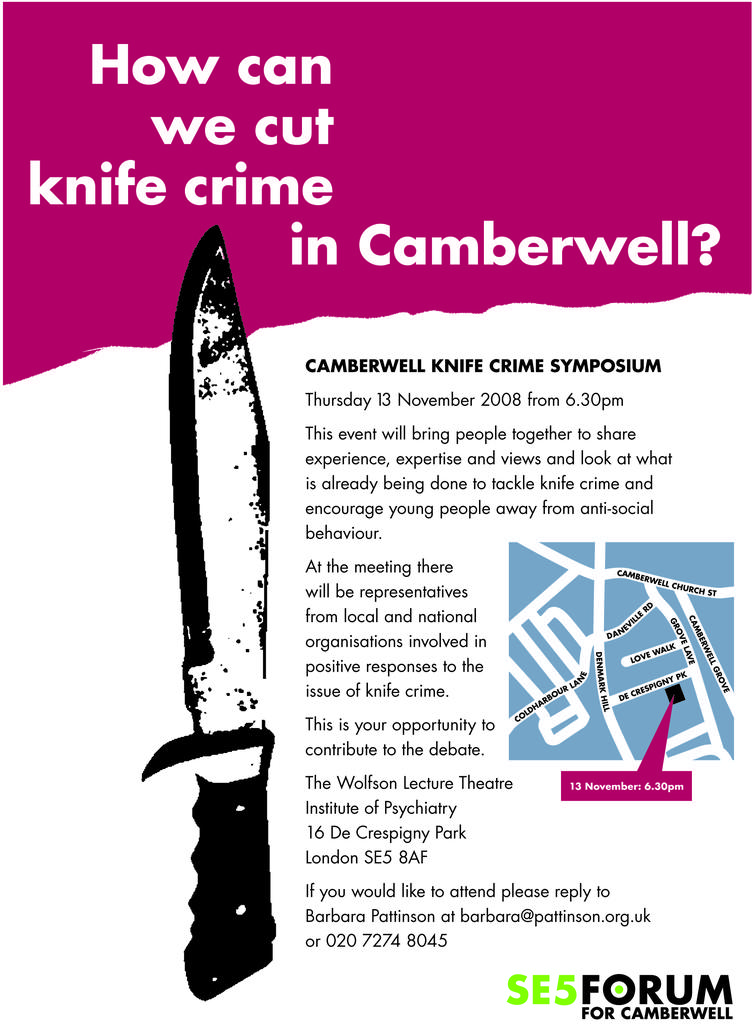What is featured on the poster in the image? There is a poster in the image, and it contains a picture of a knife. Is there any text on the poster? Yes, text is written on the poster. Reasoning: Let' Let's think step by step in order to produce the conversation. We start by identifying the main subject in the image, which is the poster. Then, we describe the specific features of the poster, including the picture of a knife and the presence of text. Each question is designed to elicit a specific detail about the image that is known from the provided facts. Absurd Question/Answer: How many oranges are being twisted on the poster? There are no oranges or any twisting action depicted on the poster; it features a picture of a knife and text. What is the health benefit of the twist mentioned on the poster? There is no mention of a twist or any health benefits on the poster; it features a picture of a knife and text. 